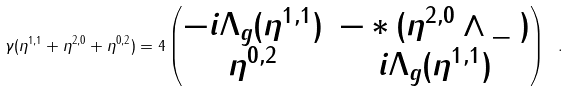<formula> <loc_0><loc_0><loc_500><loc_500>\gamma ( \eta ^ { 1 , 1 } + \eta ^ { 2 , 0 } + \eta ^ { 0 , 2 } ) = 4 \begin{pmatrix} - i \Lambda _ { g } ( \eta ^ { 1 , 1 } ) & - * ( \eta ^ { 2 , 0 } \wedge \_ \ ) \\ \eta ^ { 0 , 2 } & i \Lambda _ { g } ( \eta ^ { 1 , 1 } ) \end{pmatrix} \ .</formula> 